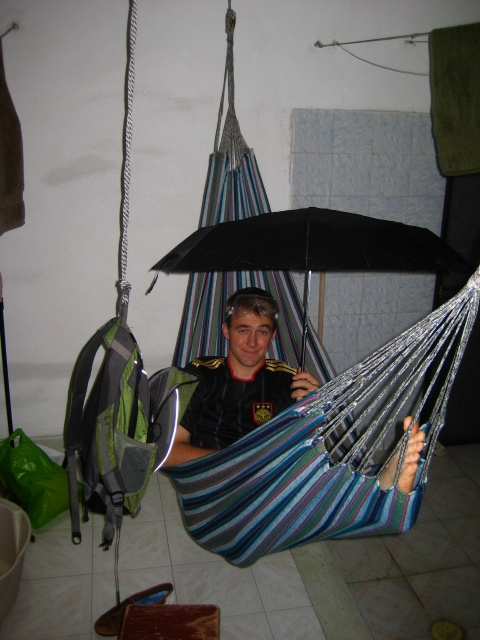What types of items are stored on the floor near the hammock? On the floor near the hammock, there appears to be a brown wooden object that might be a small stool or stand, along with some scattered items that are hard to identify from this angle. 